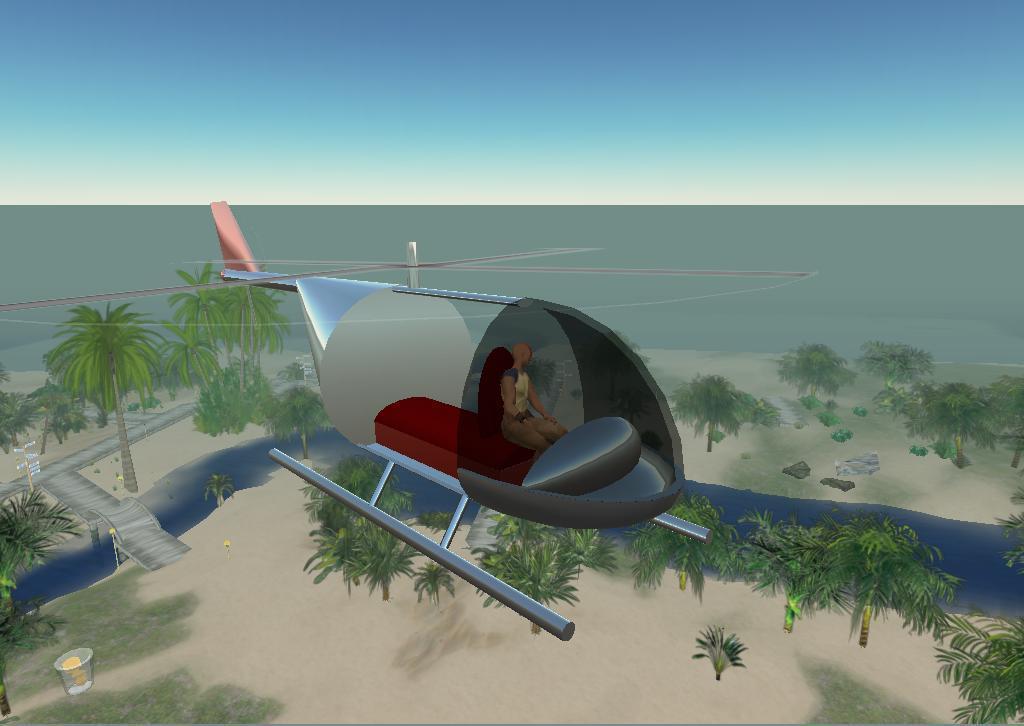Describe this image in one or two sentences. In the center of the image there is a helicopter and we can see a person in the helicopter. At the bottom there are trees and a sea. At the top there is sky. 